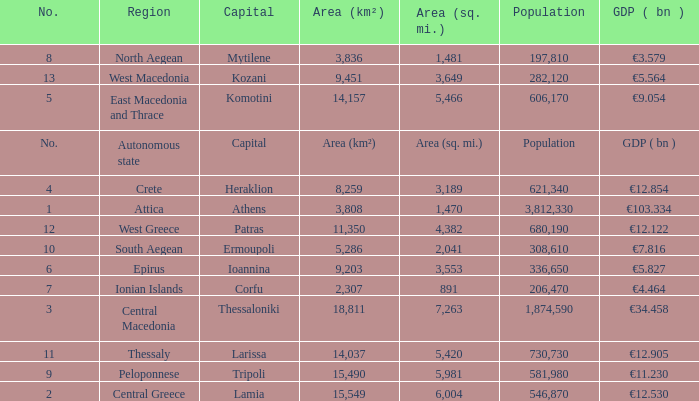What is the gdp ( bn ) where capital is capital? GDP ( bn ). 